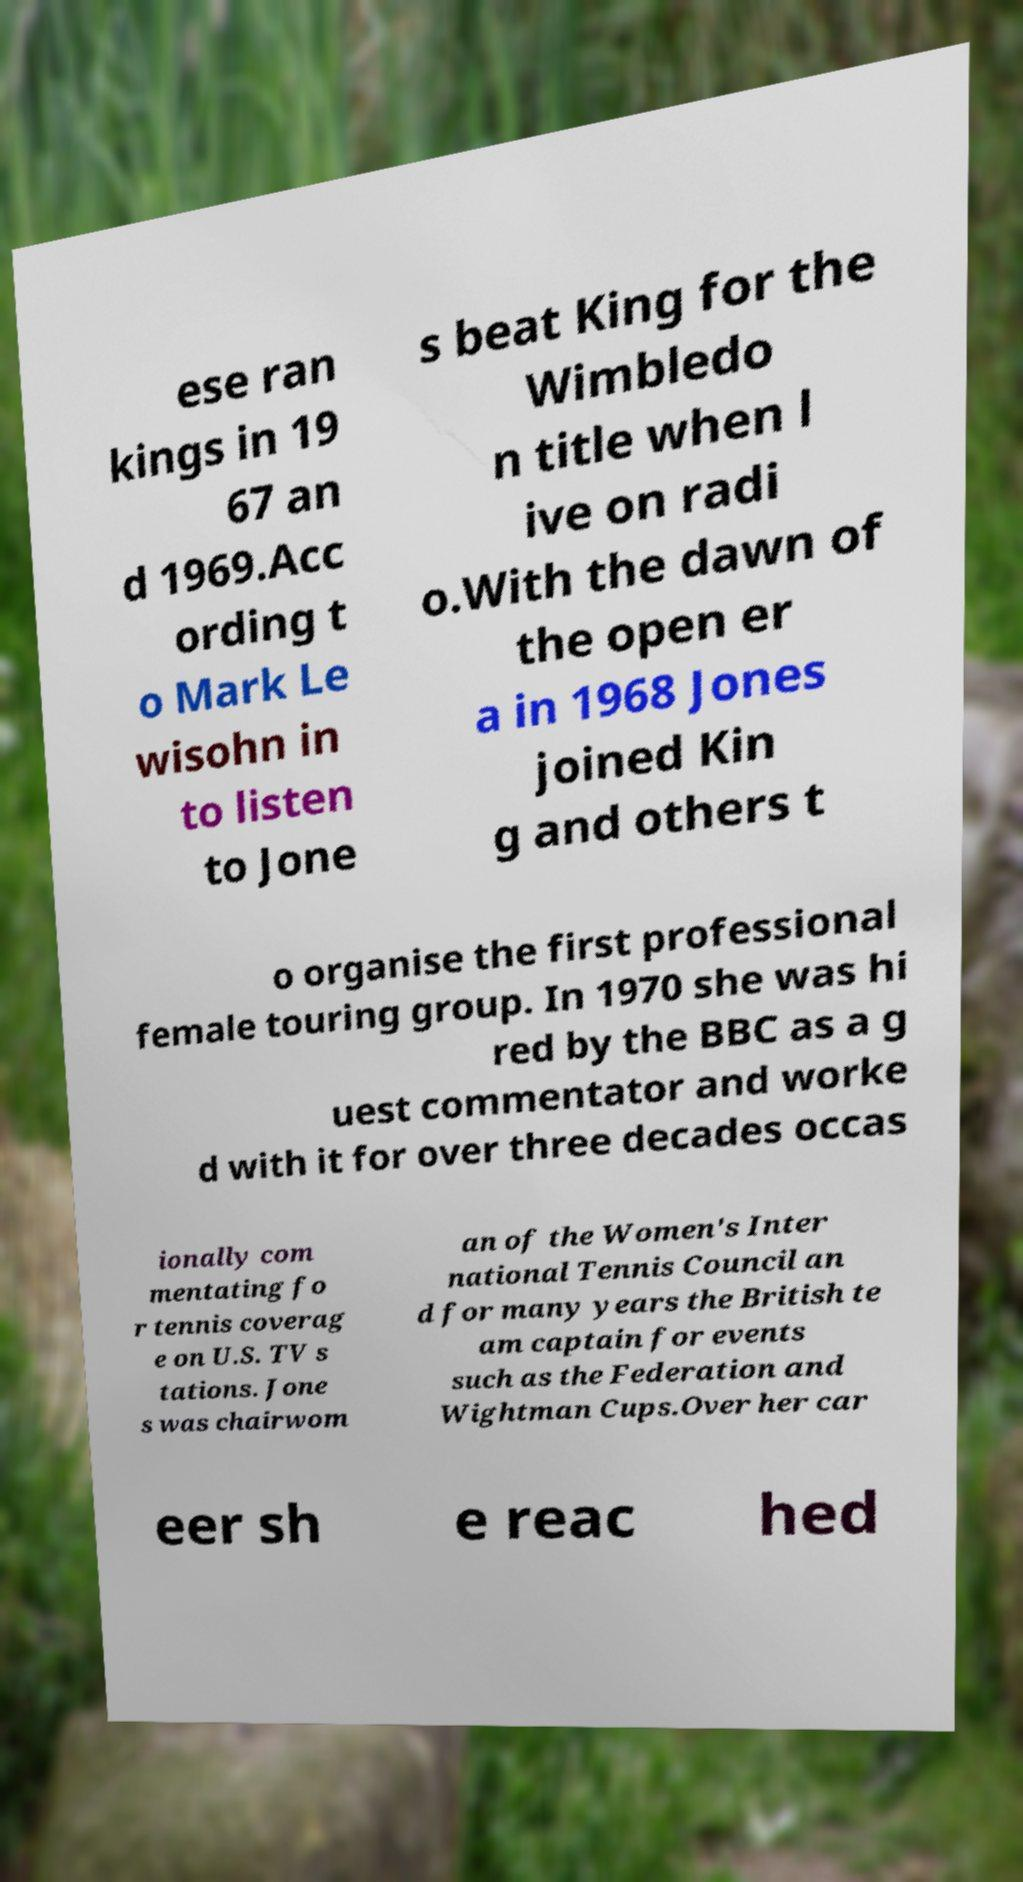Please read and relay the text visible in this image. What does it say? ese ran kings in 19 67 an d 1969.Acc ording t o Mark Le wisohn in to listen to Jone s beat King for the Wimbledo n title when l ive on radi o.With the dawn of the open er a in 1968 Jones joined Kin g and others t o organise the first professional female touring group. In 1970 she was hi red by the BBC as a g uest commentator and worke d with it for over three decades occas ionally com mentating fo r tennis coverag e on U.S. TV s tations. Jone s was chairwom an of the Women's Inter national Tennis Council an d for many years the British te am captain for events such as the Federation and Wightman Cups.Over her car eer sh e reac hed 